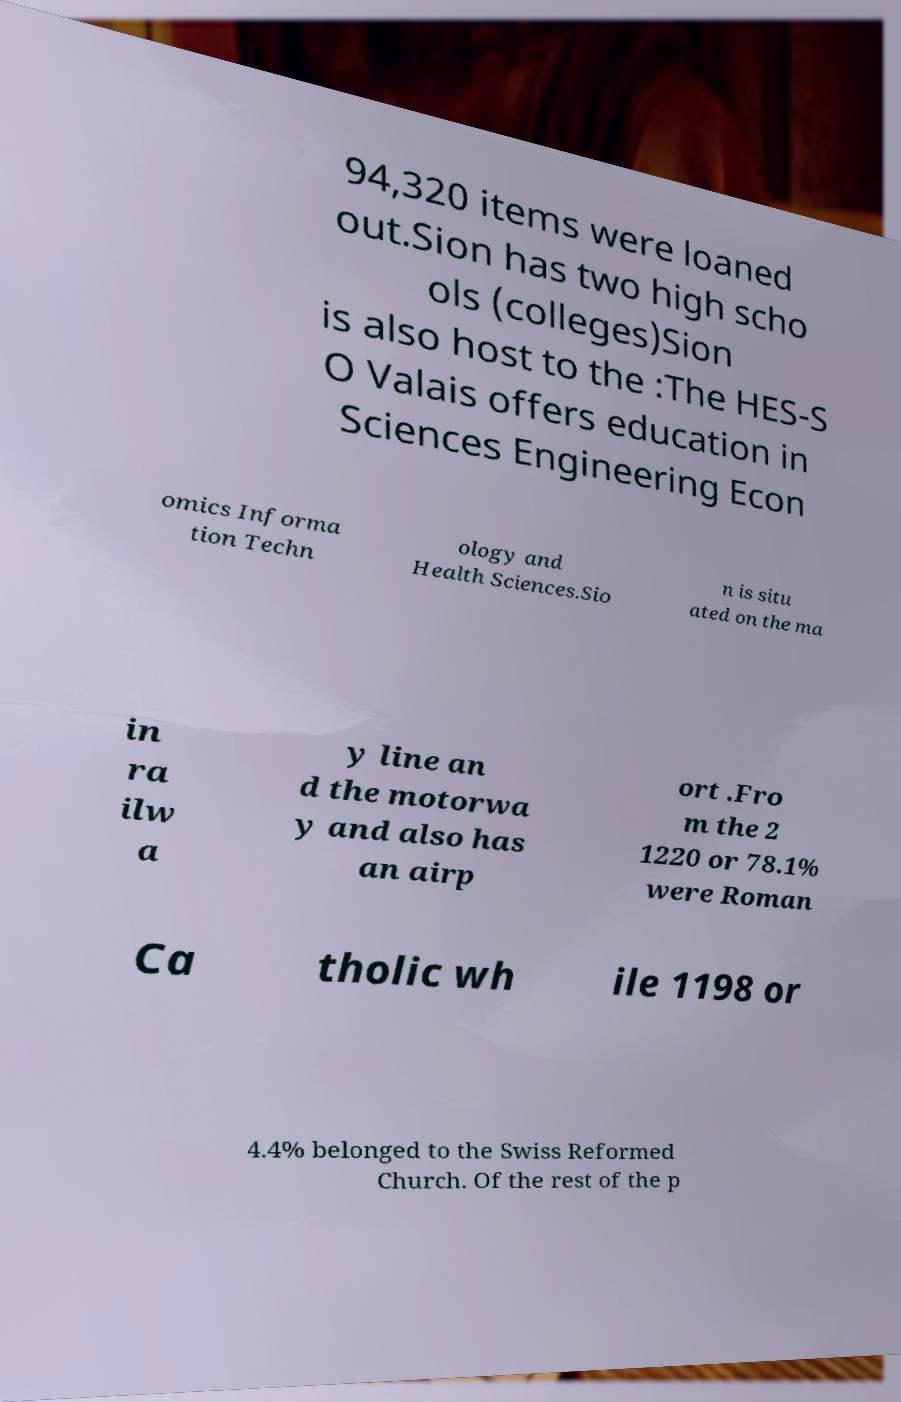Please identify and transcribe the text found in this image. 94,320 items were loaned out.Sion has two high scho ols (colleges)Sion is also host to the :The HES-S O Valais offers education in Sciences Engineering Econ omics Informa tion Techn ology and Health Sciences.Sio n is situ ated on the ma in ra ilw a y line an d the motorwa y and also has an airp ort .Fro m the 2 1220 or 78.1% were Roman Ca tholic wh ile 1198 or 4.4% belonged to the Swiss Reformed Church. Of the rest of the p 